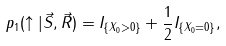Convert formula to latex. <formula><loc_0><loc_0><loc_500><loc_500>p _ { 1 } ( \uparrow | \vec { S } , \vec { R } ) = I _ { \{ X _ { 0 } > 0 \} } + \frac { 1 } { 2 } I _ { \{ X _ { 0 } = 0 \} } ,</formula> 